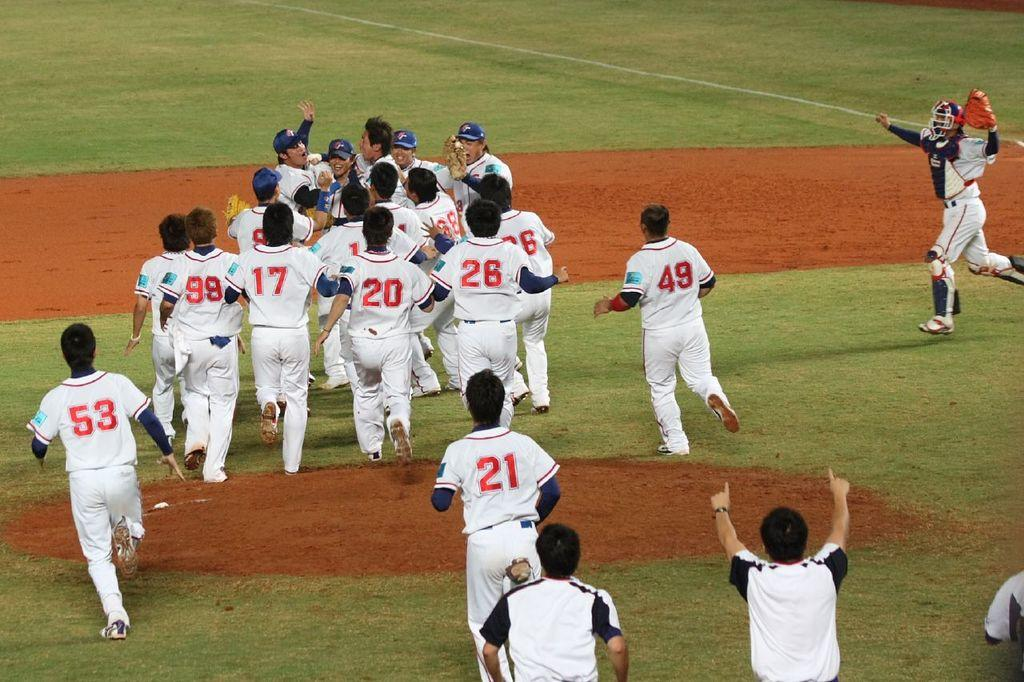<image>
Give a short and clear explanation of the subsequent image. Several baseball players are in a huddle with one having the number 21 on his back. 